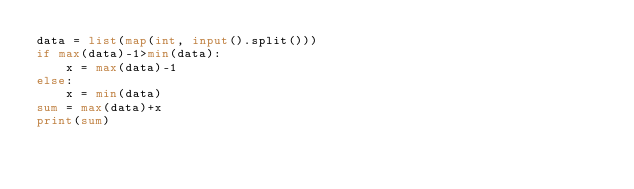Convert code to text. <code><loc_0><loc_0><loc_500><loc_500><_Python_>data = list(map(int, input().split()))
if max(data)-1>min(data):
    x = max(data)-1
else:
    x = min(data)
sum = max(data)+x
print(sum)
</code> 